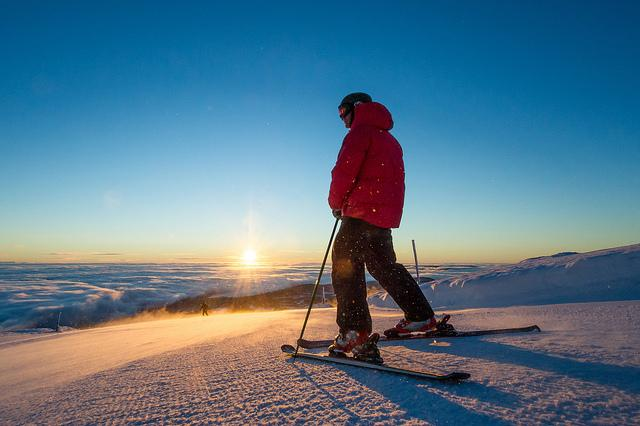Transport using skis to glide on snow is called?

Choices:
A) surfing
B) skiing
C) snowboarding
D) kiting skiing 